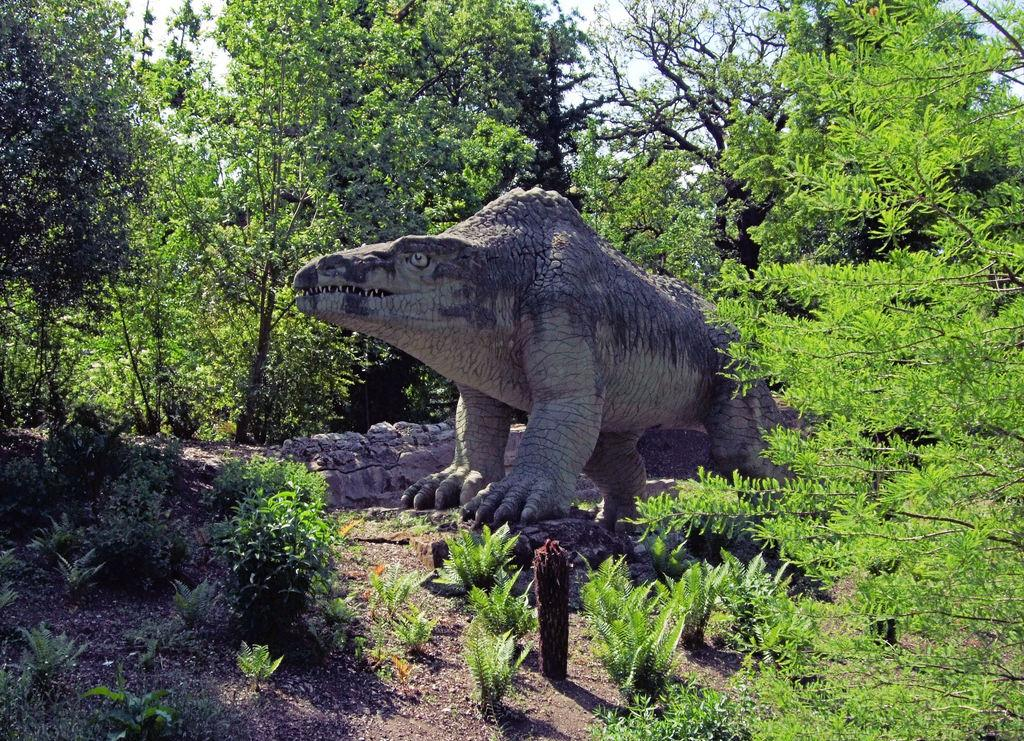What is the main subject of the image? There is a statue of an animal in the image. What can be seen in the background of the image? There are trees in the background of the image. What is the color of the trees? The trees are green. What is visible above the trees in the image? The sky is visible in the image. What is the color of the sky? The sky is white in color. Can you see any flames coming from the statue in the image? There are no flames present in the image; it features a statue of an animal and a green background with a white sky. What type of hen can be seen interacting with the statue in the image? There is no hen present in the image; it only features a statue of an animal and no other animals or creatures. 